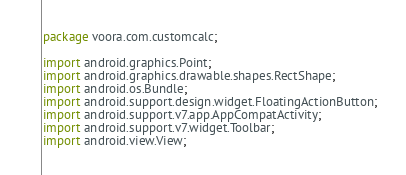Convert code to text. <code><loc_0><loc_0><loc_500><loc_500><_Java_>package voora.com.customcalc;

import android.graphics.Point;
import android.graphics.drawable.shapes.RectShape;
import android.os.Bundle;
import android.support.design.widget.FloatingActionButton;
import android.support.v7.app.AppCompatActivity;
import android.support.v7.widget.Toolbar;
import android.view.View;</code> 